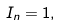<formula> <loc_0><loc_0><loc_500><loc_500>I _ { n } = 1 ,</formula> 